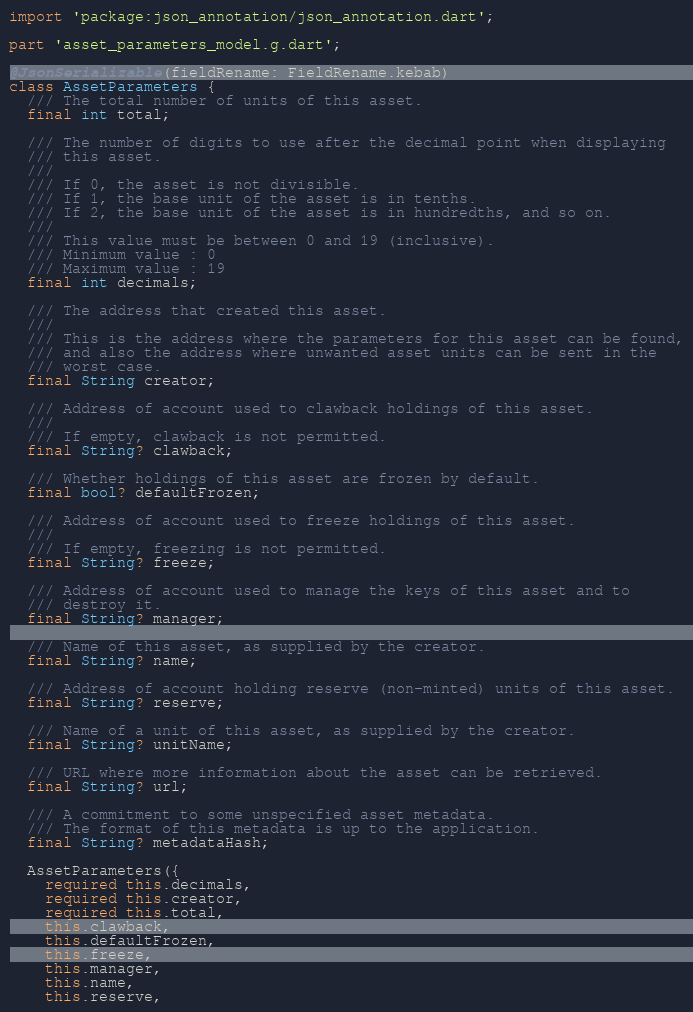<code> <loc_0><loc_0><loc_500><loc_500><_Dart_>import 'package:json_annotation/json_annotation.dart';

part 'asset_parameters_model.g.dart';

@JsonSerializable(fieldRename: FieldRename.kebab)
class AssetParameters {
  /// The total number of units of this asset.
  final int total;

  /// The number of digits to use after the decimal point when displaying
  /// this asset.
  ///
  /// If 0, the asset is not divisible.
  /// If 1, the base unit of the asset is in tenths.
  /// If 2, the base unit of the asset is in hundredths, and so on.
  ///
  /// This value must be between 0 and 19 (inclusive).
  /// Minimum value : 0
  /// Maximum value : 19
  final int decimals;

  /// The address that created this asset.
  ///
  /// This is the address where the parameters for this asset can be found,
  /// and also the address where unwanted asset units can be sent in the
  /// worst case.
  final String creator;

  /// Address of account used to clawback holdings of this asset.
  ///
  /// If empty, clawback is not permitted.
  final String? clawback;

  /// Whether holdings of this asset are frozen by default.
  final bool? defaultFrozen;

  /// Address of account used to freeze holdings of this asset.
  ///
  /// If empty, freezing is not permitted.
  final String? freeze;

  /// Address of account used to manage the keys of this asset and to
  /// destroy it.
  final String? manager;

  /// Name of this asset, as supplied by the creator.
  final String? name;

  /// Address of account holding reserve (non-minted) units of this asset.
  final String? reserve;

  /// Name of a unit of this asset, as supplied by the creator.
  final String? unitName;

  /// URL where more information about the asset can be retrieved.
  final String? url;

  /// A commitment to some unspecified asset metadata.
  /// The format of this metadata is up to the application.
  final String? metadataHash;

  AssetParameters({
    required this.decimals,
    required this.creator,
    required this.total,
    this.clawback,
    this.defaultFrozen,
    this.freeze,
    this.manager,
    this.name,
    this.reserve,</code> 